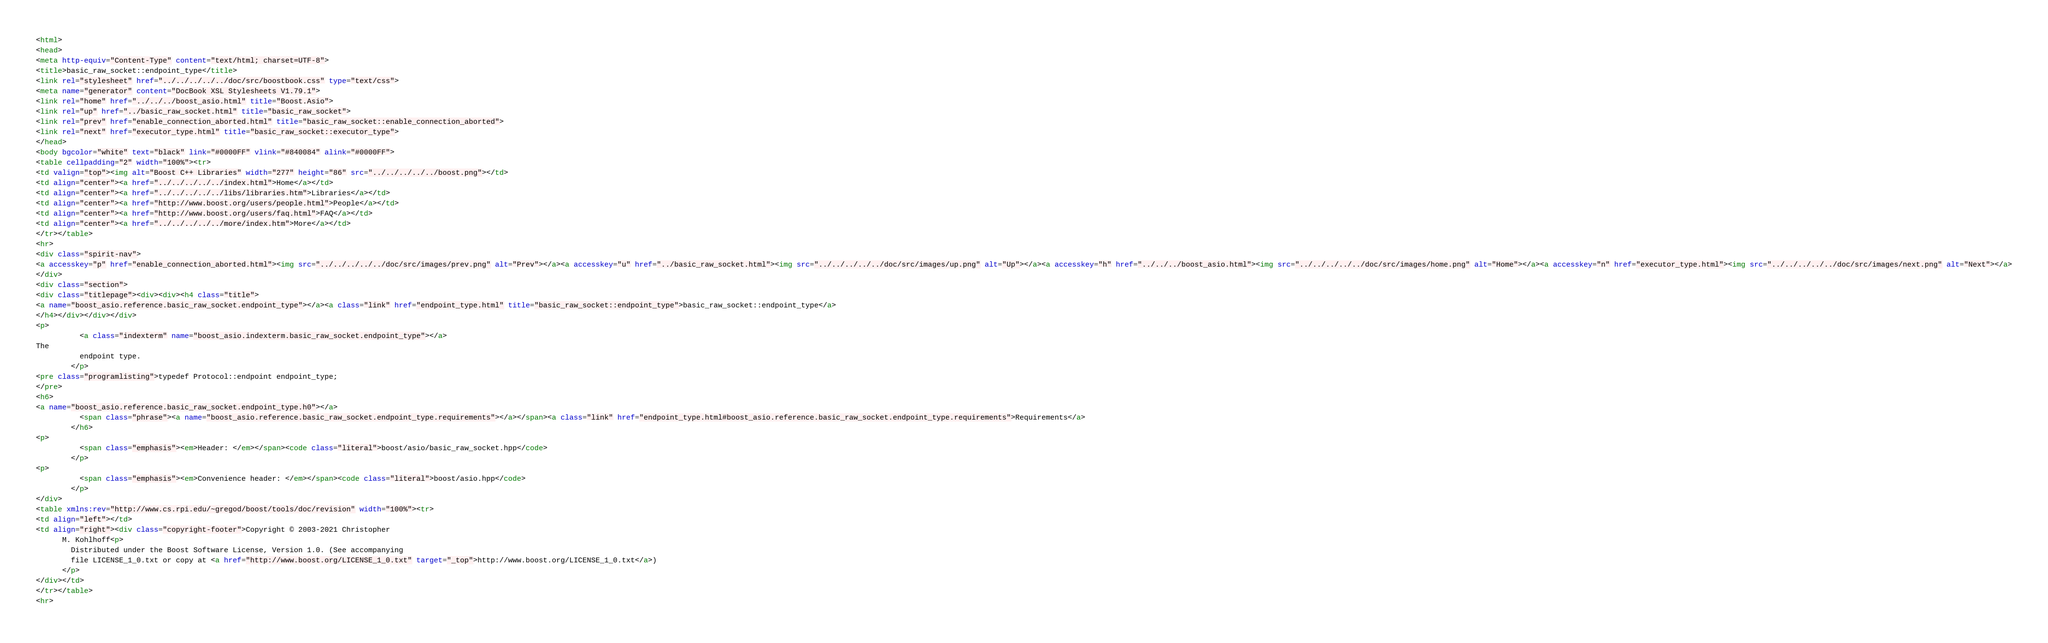Convert code to text. <code><loc_0><loc_0><loc_500><loc_500><_HTML_><html>
<head>
<meta http-equiv="Content-Type" content="text/html; charset=UTF-8">
<title>basic_raw_socket::endpoint_type</title>
<link rel="stylesheet" href="../../../../../doc/src/boostbook.css" type="text/css">
<meta name="generator" content="DocBook XSL Stylesheets V1.79.1">
<link rel="home" href="../../../boost_asio.html" title="Boost.Asio">
<link rel="up" href="../basic_raw_socket.html" title="basic_raw_socket">
<link rel="prev" href="enable_connection_aborted.html" title="basic_raw_socket::enable_connection_aborted">
<link rel="next" href="executor_type.html" title="basic_raw_socket::executor_type">
</head>
<body bgcolor="white" text="black" link="#0000FF" vlink="#840084" alink="#0000FF">
<table cellpadding="2" width="100%"><tr>
<td valign="top"><img alt="Boost C++ Libraries" width="277" height="86" src="../../../../../boost.png"></td>
<td align="center"><a href="../../../../../index.html">Home</a></td>
<td align="center"><a href="../../../../../libs/libraries.htm">Libraries</a></td>
<td align="center"><a href="http://www.boost.org/users/people.html">People</a></td>
<td align="center"><a href="http://www.boost.org/users/faq.html">FAQ</a></td>
<td align="center"><a href="../../../../../more/index.htm">More</a></td>
</tr></table>
<hr>
<div class="spirit-nav">
<a accesskey="p" href="enable_connection_aborted.html"><img src="../../../../../doc/src/images/prev.png" alt="Prev"></a><a accesskey="u" href="../basic_raw_socket.html"><img src="../../../../../doc/src/images/up.png" alt="Up"></a><a accesskey="h" href="../../../boost_asio.html"><img src="../../../../../doc/src/images/home.png" alt="Home"></a><a accesskey="n" href="executor_type.html"><img src="../../../../../doc/src/images/next.png" alt="Next"></a>
</div>
<div class="section">
<div class="titlepage"><div><div><h4 class="title">
<a name="boost_asio.reference.basic_raw_socket.endpoint_type"></a><a class="link" href="endpoint_type.html" title="basic_raw_socket::endpoint_type">basic_raw_socket::endpoint_type</a>
</h4></div></div></div>
<p>
          <a class="indexterm" name="boost_asio.indexterm.basic_raw_socket.endpoint_type"></a> 
The
          endpoint type.
        </p>
<pre class="programlisting">typedef Protocol::endpoint endpoint_type;
</pre>
<h6>
<a name="boost_asio.reference.basic_raw_socket.endpoint_type.h0"></a>
          <span class="phrase"><a name="boost_asio.reference.basic_raw_socket.endpoint_type.requirements"></a></span><a class="link" href="endpoint_type.html#boost_asio.reference.basic_raw_socket.endpoint_type.requirements">Requirements</a>
        </h6>
<p>
          <span class="emphasis"><em>Header: </em></span><code class="literal">boost/asio/basic_raw_socket.hpp</code>
        </p>
<p>
          <span class="emphasis"><em>Convenience header: </em></span><code class="literal">boost/asio.hpp</code>
        </p>
</div>
<table xmlns:rev="http://www.cs.rpi.edu/~gregod/boost/tools/doc/revision" width="100%"><tr>
<td align="left"></td>
<td align="right"><div class="copyright-footer">Copyright © 2003-2021 Christopher
      M. Kohlhoff<p>
        Distributed under the Boost Software License, Version 1.0. (See accompanying
        file LICENSE_1_0.txt or copy at <a href="http://www.boost.org/LICENSE_1_0.txt" target="_top">http://www.boost.org/LICENSE_1_0.txt</a>)
      </p>
</div></td>
</tr></table>
<hr></code> 